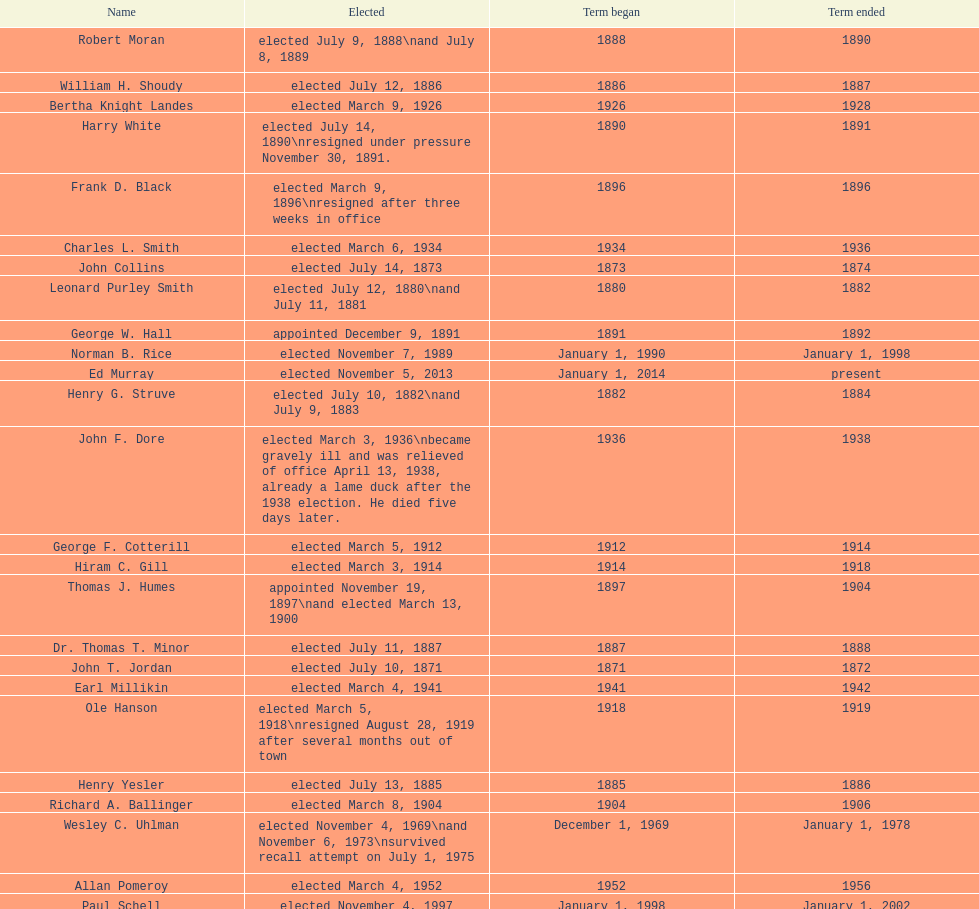Who was mayor of seattle, washington before being appointed to department of transportation during the nixon administration? James d'Orma Braman. 